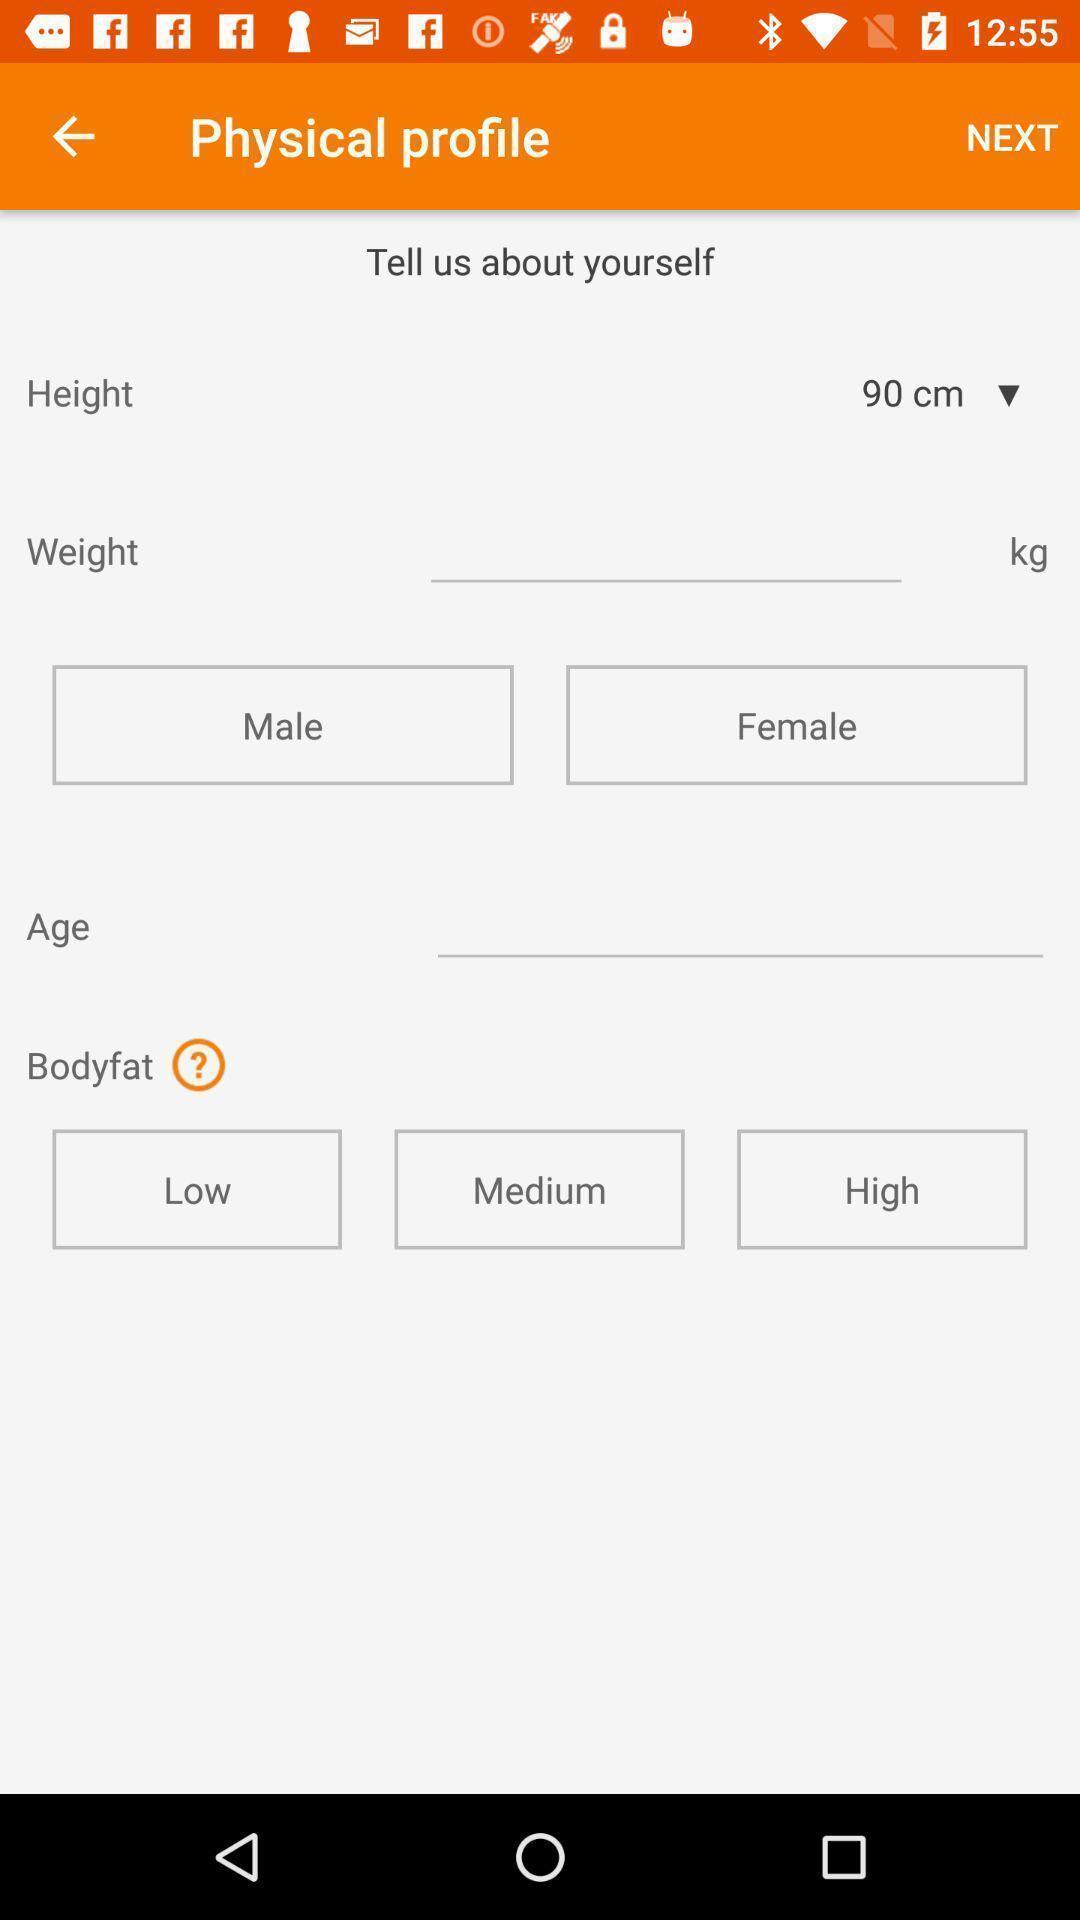Describe the key features of this screenshot. Profile page of a fitness app. 